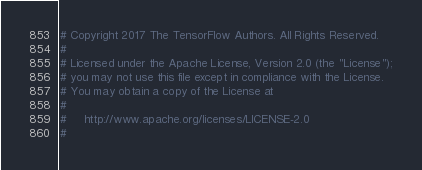<code> <loc_0><loc_0><loc_500><loc_500><_Python_># Copyright 2017 The TensorFlow Authors. All Rights Reserved.
#
# Licensed under the Apache License, Version 2.0 (the "License");
# you may not use this file except in compliance with the License.
# You may obtain a copy of the License at
#
#     http://www.apache.org/licenses/LICENSE-2.0
#</code> 